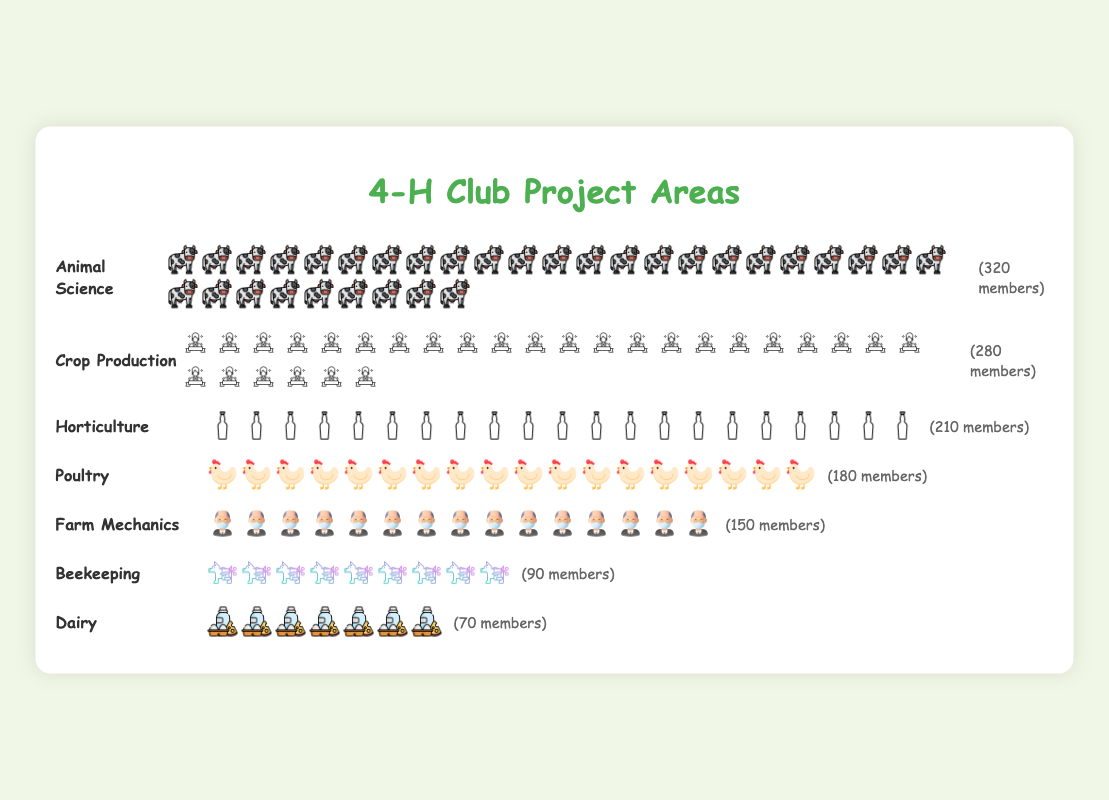What is the project area with the highest number of members? The project area with the highest number of members is represented with the most icons. According to the chart, Animal Science has the most icons.
Answer: Animal Science Which project area has the fewest members? The project area with the fewest members will be represented by the fewest icons. According to the chart, Dairy has the least number of icons.
Answer: Dairy How many more members are in Animal Science compared to Dairy? The number of members in Animal Science is 320, and the number of members in Dairy is 70. To find the difference, subtract 70 from 320. 320 - 70 = 250
Answer: 250 What is the total number of members in Crop Production and Horticulture combined? The number of members in Crop Production is 280, and in Horticulture is 210. Add these two numbers together: 280 + 210 = 490
Answer: 490 How do the number of members in Poultry compare to those in Beekeeping? The number of members in Poultry is 180 and in Beekeeping is 90. Poultry has more members.
Answer: Poultry has more members What is the average number of members across all project areas? There are 7 project areas with the following number of members: 320, 280, 210, 180, 150, 90, and 70. Sum these numbers and then divide by the number of project areas. (320 + 280 + 210 + 180 + 150 + 90 + 70) / 7 = 186.43
Answer: 186.43 Which project area has more members: Farm Mechanics or Horticulture? The number of members in Farm Mechanics is 150 and in Horticulture is 210. Horticulture has more members.
Answer: Horticulture How many icons would be used to represent members in Beekeeping if each icon represents 10 members? The number of members in Beekeeping is 90 and each icon represents 10 members. So, the number of icons is 90 divided by 10, which is 9.
Answer: 9 